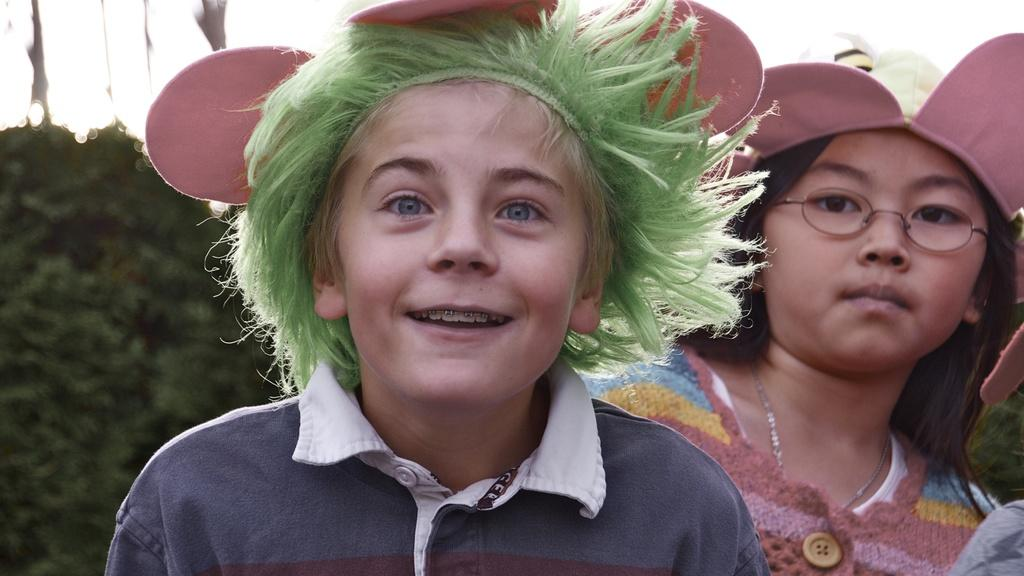How many girls are in the image? There are two girls in the image. Can you describe the positioning of the girls? One girl is standing behind the other. What is the facial expression of one of the girls? One girl is smiling. What are the girls wearing on their heads? Both girls are wearing decorated caps. What can be seen in the background of the image? There are bushes visible in the background of the image. What type of oranges are being harvested in the image? There are no oranges or plantation visible in the image. What type of skirt is the girl wearing on the right side of the image? There is no skirt visible in the image, as both girls are wearing decorated caps. 